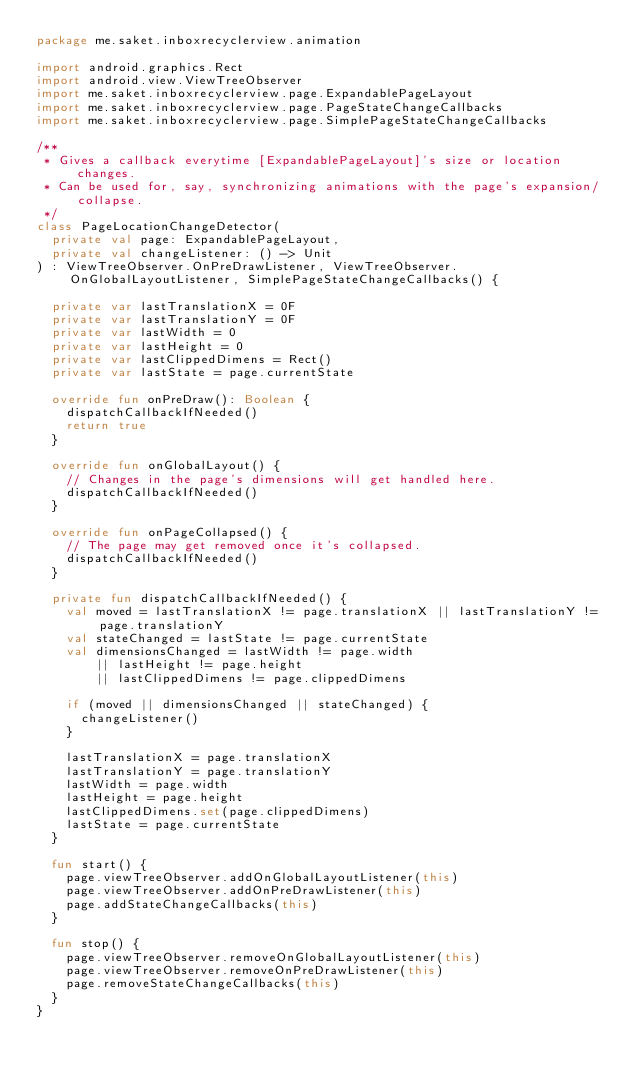<code> <loc_0><loc_0><loc_500><loc_500><_Kotlin_>package me.saket.inboxrecyclerview.animation

import android.graphics.Rect
import android.view.ViewTreeObserver
import me.saket.inboxrecyclerview.page.ExpandablePageLayout
import me.saket.inboxrecyclerview.page.PageStateChangeCallbacks
import me.saket.inboxrecyclerview.page.SimplePageStateChangeCallbacks

/**
 * Gives a callback everytime [ExpandablePageLayout]'s size or location changes.
 * Can be used for, say, synchronizing animations with the page's expansion/collapse.
 */
class PageLocationChangeDetector(
  private val page: ExpandablePageLayout,
  private val changeListener: () -> Unit
) : ViewTreeObserver.OnPreDrawListener, ViewTreeObserver.OnGlobalLayoutListener, SimplePageStateChangeCallbacks() {

  private var lastTranslationX = 0F
  private var lastTranslationY = 0F
  private var lastWidth = 0
  private var lastHeight = 0
  private var lastClippedDimens = Rect()
  private var lastState = page.currentState

  override fun onPreDraw(): Boolean {
    dispatchCallbackIfNeeded()
    return true
  }

  override fun onGlobalLayout() {
    // Changes in the page's dimensions will get handled here.
    dispatchCallbackIfNeeded()
  }

  override fun onPageCollapsed() {
    // The page may get removed once it's collapsed.
    dispatchCallbackIfNeeded()
  }

  private fun dispatchCallbackIfNeeded() {
    val moved = lastTranslationX != page.translationX || lastTranslationY != page.translationY
    val stateChanged = lastState != page.currentState
    val dimensionsChanged = lastWidth != page.width
        || lastHeight != page.height
        || lastClippedDimens != page.clippedDimens

    if (moved || dimensionsChanged || stateChanged) {
      changeListener()
    }

    lastTranslationX = page.translationX
    lastTranslationY = page.translationY
    lastWidth = page.width
    lastHeight = page.height
    lastClippedDimens.set(page.clippedDimens)
    lastState = page.currentState
  }

  fun start() {
    page.viewTreeObserver.addOnGlobalLayoutListener(this)
    page.viewTreeObserver.addOnPreDrawListener(this)
    page.addStateChangeCallbacks(this)
  }

  fun stop() {
    page.viewTreeObserver.removeOnGlobalLayoutListener(this)
    page.viewTreeObserver.removeOnPreDrawListener(this)
    page.removeStateChangeCallbacks(this)
  }
}
</code> 